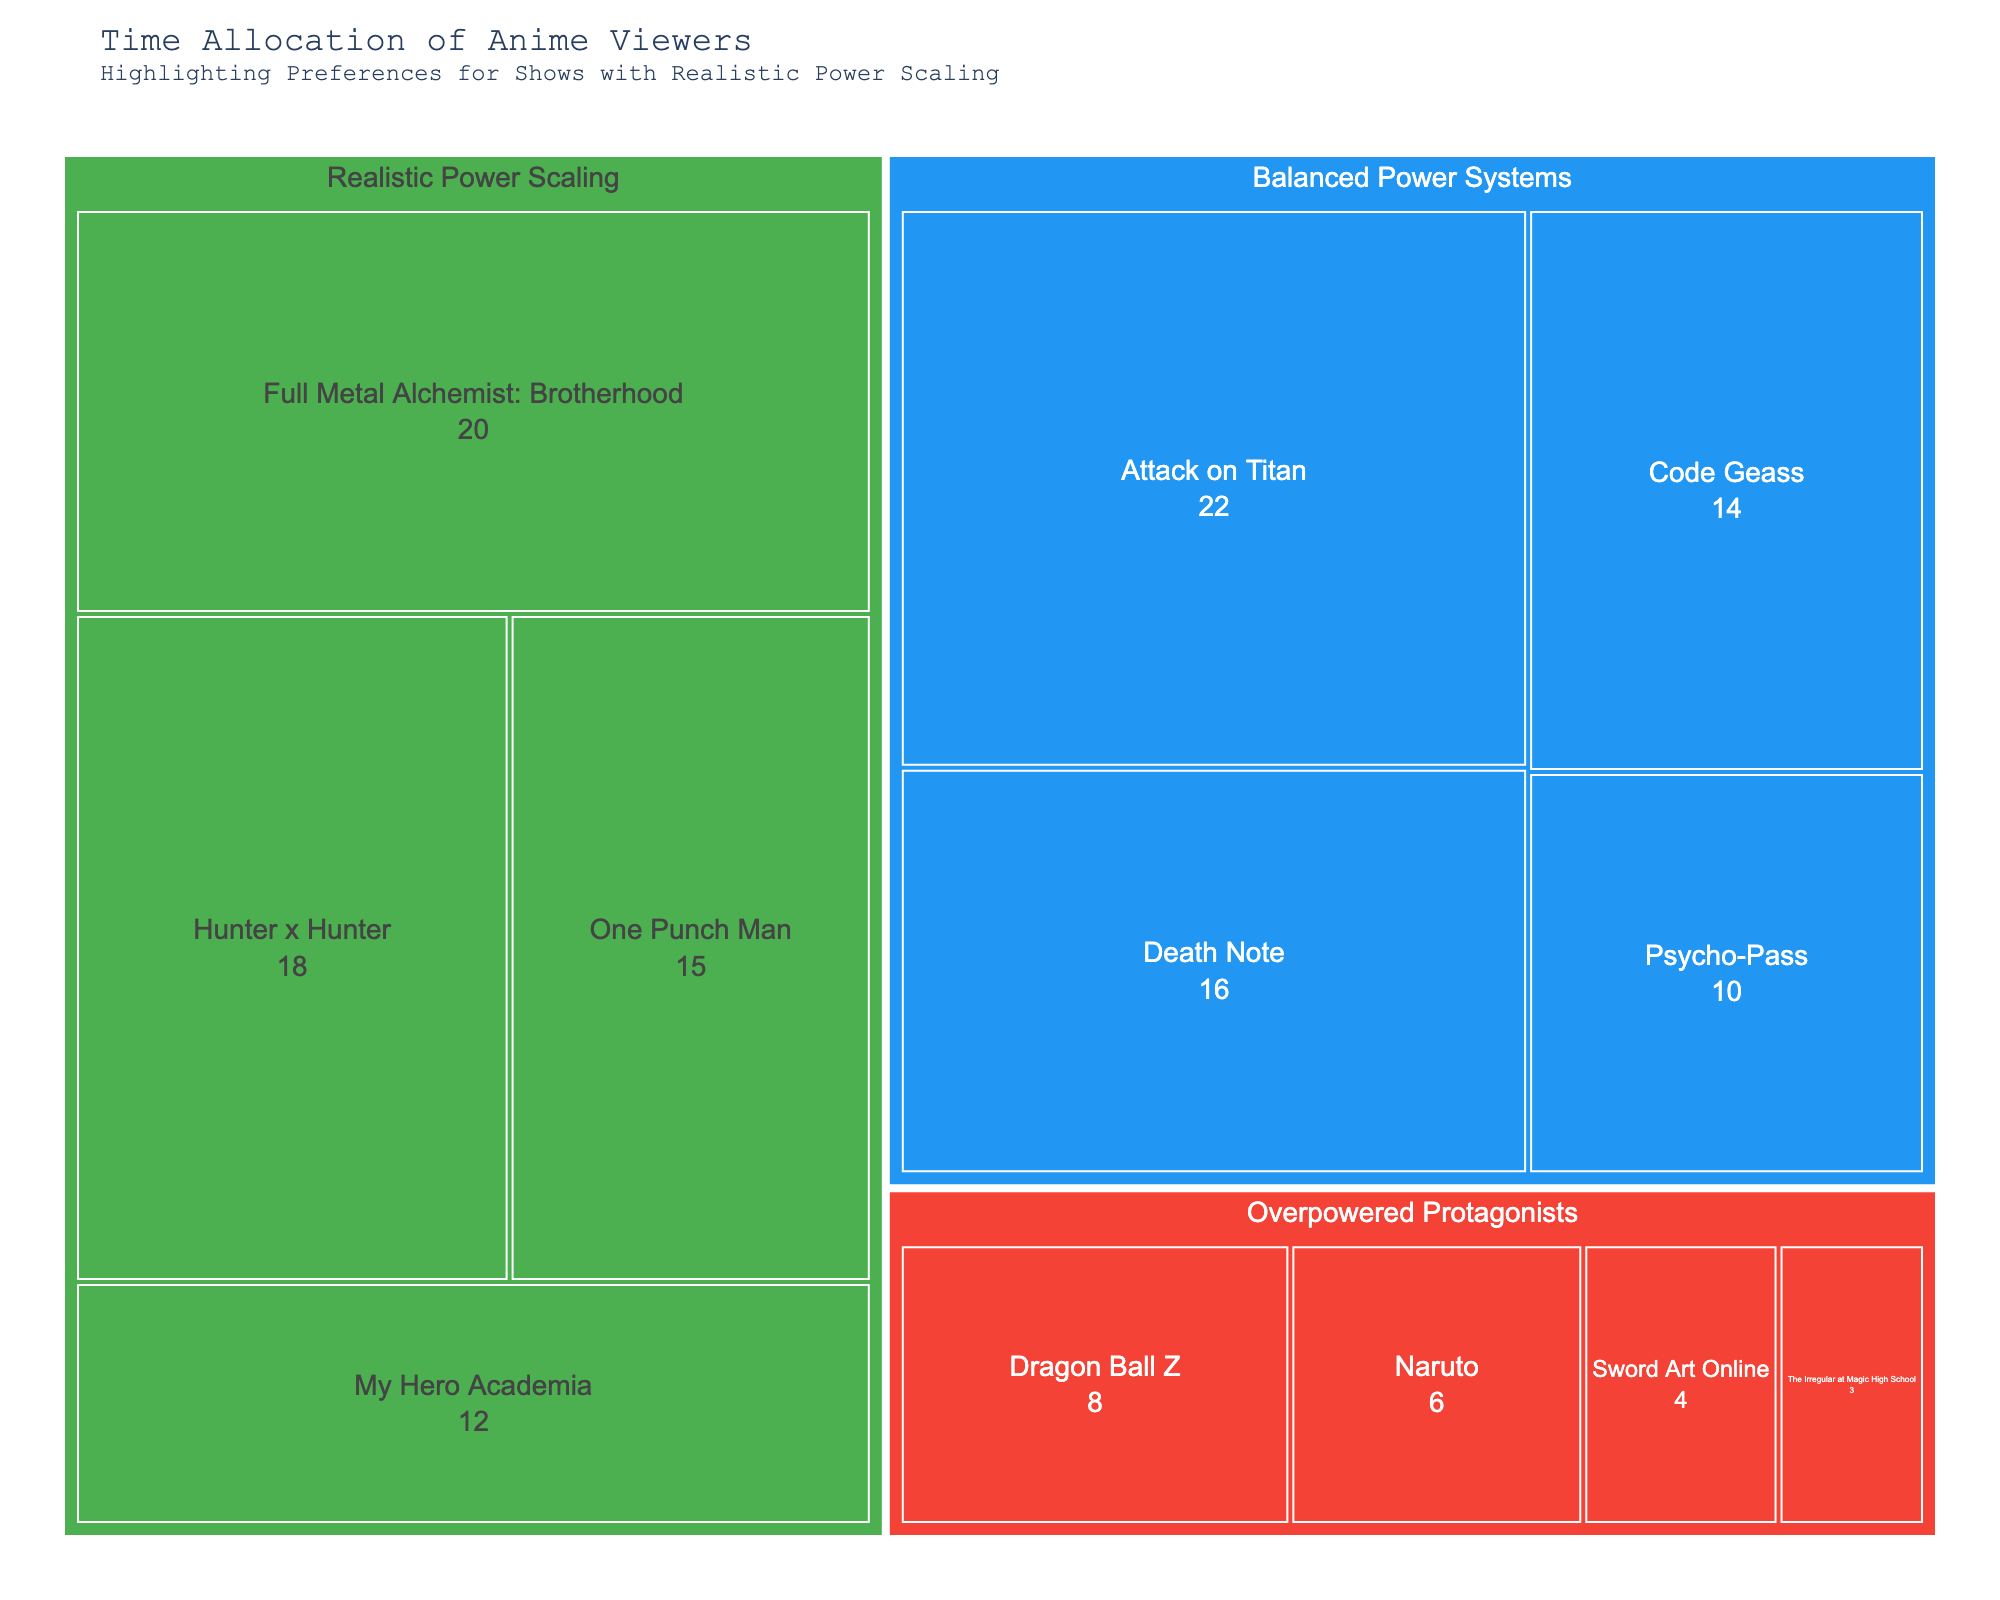What's the total number of hours spent watching anime with realistic power scaling? Sum the hours for each anime under the category "Realistic Power Scaling": One Punch Man (15) + My Hero Academia (12) + Hunter x Hunter (18) + Full Metal Alchemist: Brotherhood (20) = 65 hours.
Answer: 65 Which subcategory under "Balanced Power Systems" has the highest viewing hours? Compare the hours of each subcategory under "Balanced Power Systems": Attack on Titan (22), Death Note (16), Code Geass (14), Psycho-Pass (10). Attack on Titan has the highest number of hours with 22.
Answer: Attack on Titan Do viewers spend more time watching "Hunter x Hunter" or "Dragon Ball Z"? Compare the hours for "Hunter x Hunter" (18) with "Dragon Ball Z" (8). 18 hours is greater than 8 hours.
Answer: Hunter x Hunter Which category has the least total viewing hours? Sum the hours for each category: 
- "Realistic Power Scaling": 15 + 12 + 18 + 20 = 65 
- "Overpowered Protagonists": 8 + 6 + 4 + 3 = 21
- "Balanced Power Systems": 22 + 16 + 14 + 10 = 62 
"Overpowered Protagonists" has the least total viewing hours with 21.
Answer: Overpowered Protagonists What's the difference in viewing hours between "Sword Art Online" and "Psycho-Pass"? Subtract the hours of "Sword Art Online" (4) from "Psycho-Pass" (10): 10 - 4 = 6 hours.
Answer: 6 How many more hours are spent watching "Full Metal Alchemist: Brotherhood" than "Naruto"? Subtract the hours of "Naruto" (6) from "Full Metal Alchemist: Brotherhood" (20): 20 - 6 = 14 hours.
Answer: 14 Which subcategory has the lowest viewing hours? Compare the hours of all subcategories: The Irregular at Magic High School (3) has the lowest number of hours.
Answer: The Irregular at Magic High School How much time is spent on anime with balanced power systems compared to overpowered protagonists? Sum the hours for each category:
- "Balanced Power Systems": 22 + 16 + 14 + 10 = 62 
- "Overpowered Protagonists": 8 + 6 + 4 + 3 = 21 
62 hours for balanced power systems vs 21 hours for overpowered protagonists.
Answer: 62 to 21 What's the average viewing time for the "Realistic Power Scaling" category? Sum the hours for "Realistic Power Scaling" (65) and divide by the number of subcategories (4): 65 / 4 = 16.25 hours.
Answer: 16.25 